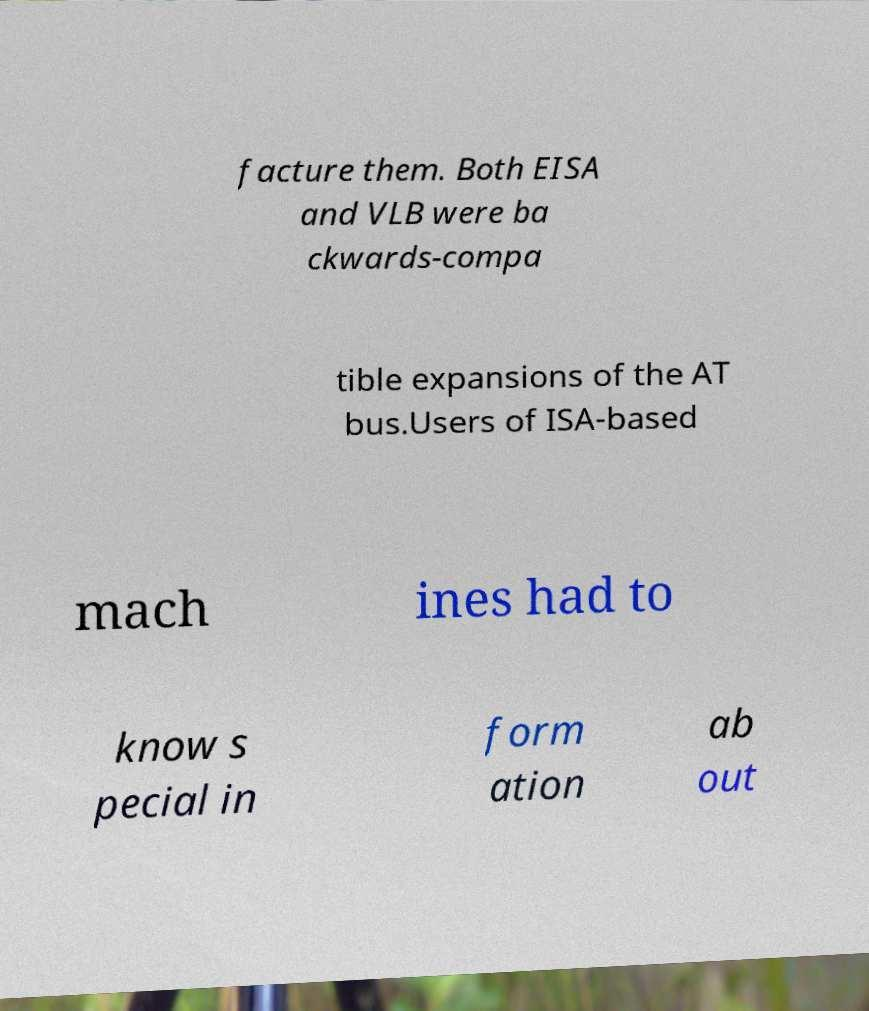Please read and relay the text visible in this image. What does it say? facture them. Both EISA and VLB were ba ckwards-compa tible expansions of the AT bus.Users of ISA-based mach ines had to know s pecial in form ation ab out 